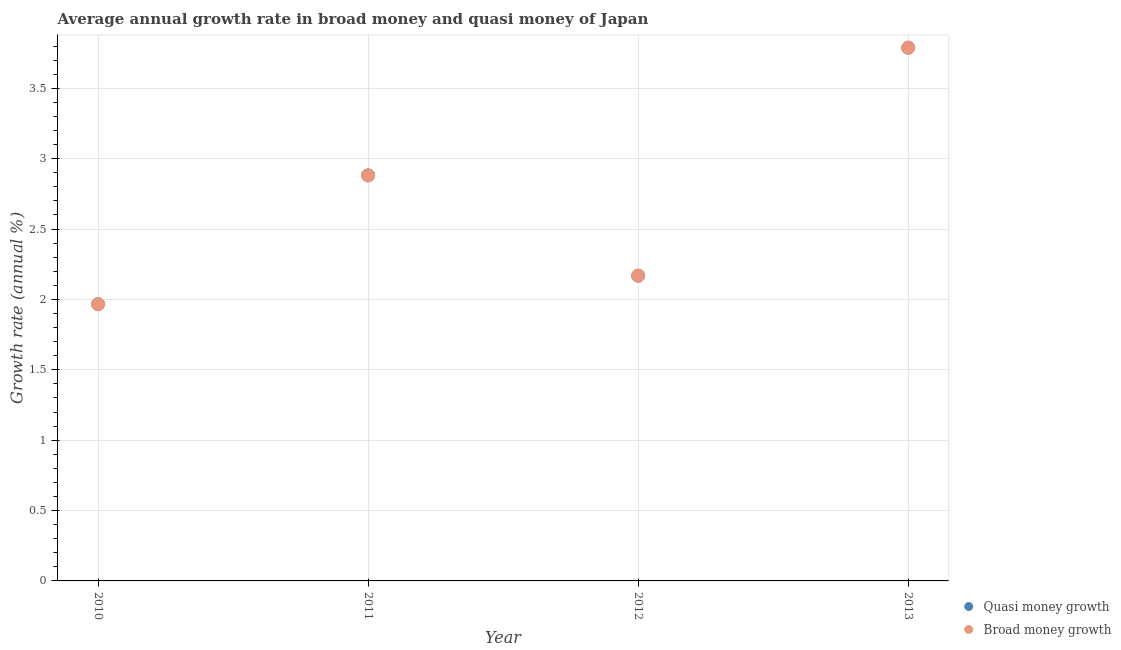What is the annual growth rate in broad money in 2011?
Your answer should be compact. 2.88. Across all years, what is the maximum annual growth rate in quasi money?
Give a very brief answer. 3.79. Across all years, what is the minimum annual growth rate in quasi money?
Your answer should be very brief. 1.97. In which year was the annual growth rate in quasi money minimum?
Keep it short and to the point. 2010. What is the total annual growth rate in broad money in the graph?
Make the answer very short. 10.8. What is the difference between the annual growth rate in quasi money in 2010 and that in 2011?
Keep it short and to the point. -0.92. What is the difference between the annual growth rate in quasi money in 2011 and the annual growth rate in broad money in 2012?
Your answer should be very brief. 0.71. What is the average annual growth rate in broad money per year?
Offer a terse response. 2.7. What is the ratio of the annual growth rate in quasi money in 2010 to that in 2011?
Your answer should be compact. 0.68. Is the difference between the annual growth rate in broad money in 2011 and 2013 greater than the difference between the annual growth rate in quasi money in 2011 and 2013?
Provide a short and direct response. No. What is the difference between the highest and the second highest annual growth rate in quasi money?
Your response must be concise. 0.91. What is the difference between the highest and the lowest annual growth rate in quasi money?
Your answer should be very brief. 1.82. Does the annual growth rate in broad money monotonically increase over the years?
Ensure brevity in your answer.  No. How many dotlines are there?
Offer a very short reply. 2. How many years are there in the graph?
Offer a terse response. 4. What is the difference between two consecutive major ticks on the Y-axis?
Ensure brevity in your answer.  0.5. Does the graph contain any zero values?
Provide a short and direct response. No. What is the title of the graph?
Keep it short and to the point. Average annual growth rate in broad money and quasi money of Japan. What is the label or title of the X-axis?
Ensure brevity in your answer.  Year. What is the label or title of the Y-axis?
Offer a terse response. Growth rate (annual %). What is the Growth rate (annual %) of Quasi money growth in 2010?
Offer a very short reply. 1.97. What is the Growth rate (annual %) in Broad money growth in 2010?
Provide a short and direct response. 1.97. What is the Growth rate (annual %) in Quasi money growth in 2011?
Provide a short and direct response. 2.88. What is the Growth rate (annual %) of Broad money growth in 2011?
Keep it short and to the point. 2.88. What is the Growth rate (annual %) of Quasi money growth in 2012?
Make the answer very short. 2.17. What is the Growth rate (annual %) of Broad money growth in 2012?
Provide a succinct answer. 2.17. What is the Growth rate (annual %) in Quasi money growth in 2013?
Your response must be concise. 3.79. What is the Growth rate (annual %) of Broad money growth in 2013?
Provide a short and direct response. 3.79. Across all years, what is the maximum Growth rate (annual %) of Quasi money growth?
Make the answer very short. 3.79. Across all years, what is the maximum Growth rate (annual %) of Broad money growth?
Your answer should be very brief. 3.79. Across all years, what is the minimum Growth rate (annual %) in Quasi money growth?
Offer a terse response. 1.97. Across all years, what is the minimum Growth rate (annual %) of Broad money growth?
Offer a terse response. 1.97. What is the total Growth rate (annual %) of Quasi money growth in the graph?
Provide a short and direct response. 10.8. What is the total Growth rate (annual %) of Broad money growth in the graph?
Your answer should be very brief. 10.8. What is the difference between the Growth rate (annual %) of Quasi money growth in 2010 and that in 2011?
Offer a terse response. -0.92. What is the difference between the Growth rate (annual %) of Broad money growth in 2010 and that in 2011?
Make the answer very short. -0.92. What is the difference between the Growth rate (annual %) in Quasi money growth in 2010 and that in 2012?
Make the answer very short. -0.2. What is the difference between the Growth rate (annual %) in Broad money growth in 2010 and that in 2012?
Keep it short and to the point. -0.2. What is the difference between the Growth rate (annual %) in Quasi money growth in 2010 and that in 2013?
Your answer should be compact. -1.82. What is the difference between the Growth rate (annual %) of Broad money growth in 2010 and that in 2013?
Ensure brevity in your answer.  -1.82. What is the difference between the Growth rate (annual %) of Quasi money growth in 2011 and that in 2012?
Keep it short and to the point. 0.71. What is the difference between the Growth rate (annual %) in Broad money growth in 2011 and that in 2012?
Make the answer very short. 0.71. What is the difference between the Growth rate (annual %) in Quasi money growth in 2011 and that in 2013?
Give a very brief answer. -0.91. What is the difference between the Growth rate (annual %) of Broad money growth in 2011 and that in 2013?
Provide a short and direct response. -0.91. What is the difference between the Growth rate (annual %) in Quasi money growth in 2012 and that in 2013?
Your answer should be very brief. -1.62. What is the difference between the Growth rate (annual %) in Broad money growth in 2012 and that in 2013?
Provide a succinct answer. -1.62. What is the difference between the Growth rate (annual %) of Quasi money growth in 2010 and the Growth rate (annual %) of Broad money growth in 2011?
Provide a succinct answer. -0.92. What is the difference between the Growth rate (annual %) in Quasi money growth in 2010 and the Growth rate (annual %) in Broad money growth in 2012?
Your answer should be compact. -0.2. What is the difference between the Growth rate (annual %) in Quasi money growth in 2010 and the Growth rate (annual %) in Broad money growth in 2013?
Provide a succinct answer. -1.82. What is the difference between the Growth rate (annual %) of Quasi money growth in 2011 and the Growth rate (annual %) of Broad money growth in 2012?
Give a very brief answer. 0.71. What is the difference between the Growth rate (annual %) of Quasi money growth in 2011 and the Growth rate (annual %) of Broad money growth in 2013?
Give a very brief answer. -0.91. What is the difference between the Growth rate (annual %) in Quasi money growth in 2012 and the Growth rate (annual %) in Broad money growth in 2013?
Your response must be concise. -1.62. What is the average Growth rate (annual %) of Quasi money growth per year?
Keep it short and to the point. 2.7. What is the average Growth rate (annual %) in Broad money growth per year?
Offer a terse response. 2.7. In the year 2010, what is the difference between the Growth rate (annual %) of Quasi money growth and Growth rate (annual %) of Broad money growth?
Ensure brevity in your answer.  0. In the year 2012, what is the difference between the Growth rate (annual %) in Quasi money growth and Growth rate (annual %) in Broad money growth?
Your answer should be very brief. 0. What is the ratio of the Growth rate (annual %) in Quasi money growth in 2010 to that in 2011?
Ensure brevity in your answer.  0.68. What is the ratio of the Growth rate (annual %) of Broad money growth in 2010 to that in 2011?
Give a very brief answer. 0.68. What is the ratio of the Growth rate (annual %) of Quasi money growth in 2010 to that in 2012?
Make the answer very short. 0.91. What is the ratio of the Growth rate (annual %) in Broad money growth in 2010 to that in 2012?
Offer a very short reply. 0.91. What is the ratio of the Growth rate (annual %) of Quasi money growth in 2010 to that in 2013?
Give a very brief answer. 0.52. What is the ratio of the Growth rate (annual %) of Broad money growth in 2010 to that in 2013?
Your answer should be compact. 0.52. What is the ratio of the Growth rate (annual %) in Quasi money growth in 2011 to that in 2012?
Provide a short and direct response. 1.33. What is the ratio of the Growth rate (annual %) in Broad money growth in 2011 to that in 2012?
Make the answer very short. 1.33. What is the ratio of the Growth rate (annual %) in Quasi money growth in 2011 to that in 2013?
Give a very brief answer. 0.76. What is the ratio of the Growth rate (annual %) of Broad money growth in 2011 to that in 2013?
Keep it short and to the point. 0.76. What is the ratio of the Growth rate (annual %) of Quasi money growth in 2012 to that in 2013?
Offer a terse response. 0.57. What is the ratio of the Growth rate (annual %) of Broad money growth in 2012 to that in 2013?
Ensure brevity in your answer.  0.57. What is the difference between the highest and the second highest Growth rate (annual %) of Quasi money growth?
Give a very brief answer. 0.91. What is the difference between the highest and the second highest Growth rate (annual %) in Broad money growth?
Provide a short and direct response. 0.91. What is the difference between the highest and the lowest Growth rate (annual %) in Quasi money growth?
Your answer should be very brief. 1.82. What is the difference between the highest and the lowest Growth rate (annual %) of Broad money growth?
Ensure brevity in your answer.  1.82. 